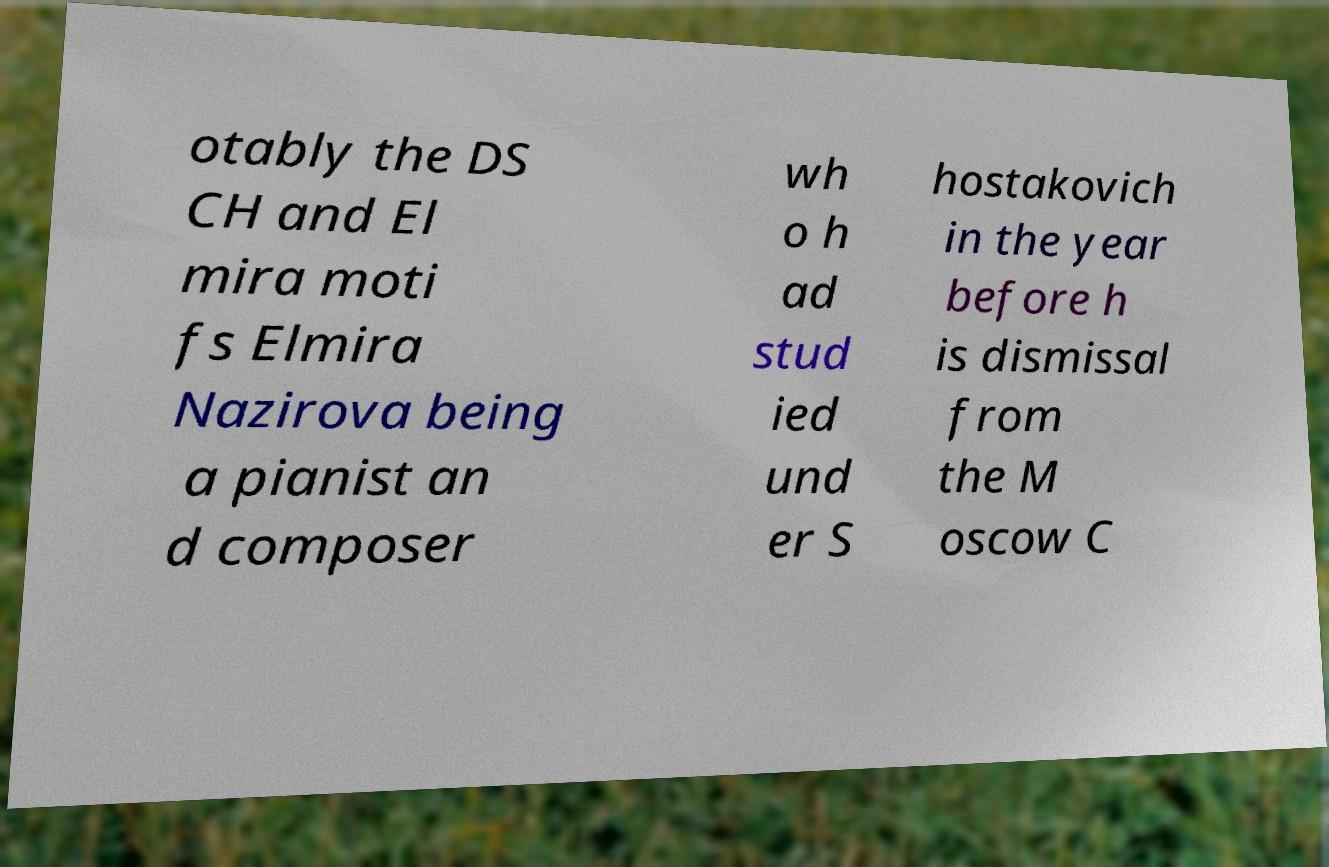For documentation purposes, I need the text within this image transcribed. Could you provide that? otably the DS CH and El mira moti fs Elmira Nazirova being a pianist an d composer wh o h ad stud ied und er S hostakovich in the year before h is dismissal from the M oscow C 